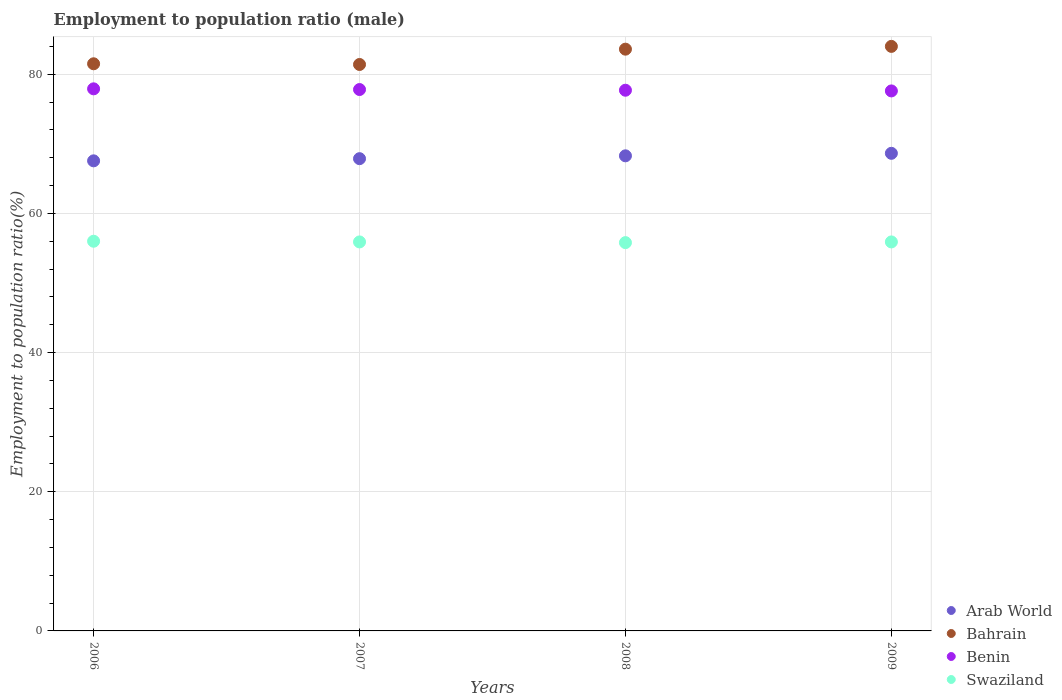How many different coloured dotlines are there?
Ensure brevity in your answer.  4. Across all years, what is the maximum employment to population ratio in Swaziland?
Ensure brevity in your answer.  56. Across all years, what is the minimum employment to population ratio in Swaziland?
Your answer should be very brief. 55.8. In which year was the employment to population ratio in Arab World minimum?
Your answer should be compact. 2006. What is the total employment to population ratio in Benin in the graph?
Keep it short and to the point. 311. What is the difference between the employment to population ratio in Swaziland in 2006 and that in 2009?
Your answer should be very brief. 0.1. What is the average employment to population ratio in Arab World per year?
Offer a terse response. 68.08. In the year 2006, what is the difference between the employment to population ratio in Benin and employment to population ratio in Swaziland?
Provide a succinct answer. 21.9. In how many years, is the employment to population ratio in Swaziland greater than 64 %?
Offer a very short reply. 0. What is the ratio of the employment to population ratio in Bahrain in 2006 to that in 2008?
Your answer should be very brief. 0.97. Is the employment to population ratio in Benin in 2006 less than that in 2007?
Offer a very short reply. No. What is the difference between the highest and the second highest employment to population ratio in Swaziland?
Offer a terse response. 0.1. What is the difference between the highest and the lowest employment to population ratio in Bahrain?
Your answer should be very brief. 2.6. In how many years, is the employment to population ratio in Swaziland greater than the average employment to population ratio in Swaziland taken over all years?
Ensure brevity in your answer.  3. Is the sum of the employment to population ratio in Bahrain in 2006 and 2007 greater than the maximum employment to population ratio in Swaziland across all years?
Your answer should be compact. Yes. Is it the case that in every year, the sum of the employment to population ratio in Swaziland and employment to population ratio in Bahrain  is greater than the sum of employment to population ratio in Arab World and employment to population ratio in Benin?
Keep it short and to the point. Yes. Is it the case that in every year, the sum of the employment to population ratio in Arab World and employment to population ratio in Swaziland  is greater than the employment to population ratio in Bahrain?
Give a very brief answer. Yes. Does the employment to population ratio in Benin monotonically increase over the years?
Ensure brevity in your answer.  No. Is the employment to population ratio in Arab World strictly less than the employment to population ratio in Bahrain over the years?
Your answer should be compact. Yes. How many dotlines are there?
Make the answer very short. 4. How many years are there in the graph?
Provide a short and direct response. 4. Are the values on the major ticks of Y-axis written in scientific E-notation?
Offer a terse response. No. Does the graph contain grids?
Keep it short and to the point. Yes. Where does the legend appear in the graph?
Provide a short and direct response. Bottom right. What is the title of the graph?
Provide a short and direct response. Employment to population ratio (male). What is the label or title of the X-axis?
Your answer should be very brief. Years. What is the label or title of the Y-axis?
Your response must be concise. Employment to population ratio(%). What is the Employment to population ratio(%) of Arab World in 2006?
Provide a short and direct response. 67.55. What is the Employment to population ratio(%) in Bahrain in 2006?
Offer a very short reply. 81.5. What is the Employment to population ratio(%) of Benin in 2006?
Make the answer very short. 77.9. What is the Employment to population ratio(%) in Arab World in 2007?
Give a very brief answer. 67.86. What is the Employment to population ratio(%) in Bahrain in 2007?
Offer a very short reply. 81.4. What is the Employment to population ratio(%) in Benin in 2007?
Provide a short and direct response. 77.8. What is the Employment to population ratio(%) in Swaziland in 2007?
Provide a short and direct response. 55.9. What is the Employment to population ratio(%) in Arab World in 2008?
Ensure brevity in your answer.  68.27. What is the Employment to population ratio(%) in Bahrain in 2008?
Keep it short and to the point. 83.6. What is the Employment to population ratio(%) of Benin in 2008?
Offer a very short reply. 77.7. What is the Employment to population ratio(%) in Swaziland in 2008?
Your answer should be compact. 55.8. What is the Employment to population ratio(%) of Arab World in 2009?
Make the answer very short. 68.63. What is the Employment to population ratio(%) in Benin in 2009?
Provide a short and direct response. 77.6. What is the Employment to population ratio(%) of Swaziland in 2009?
Offer a terse response. 55.9. Across all years, what is the maximum Employment to population ratio(%) of Arab World?
Keep it short and to the point. 68.63. Across all years, what is the maximum Employment to population ratio(%) in Benin?
Ensure brevity in your answer.  77.9. Across all years, what is the maximum Employment to population ratio(%) in Swaziland?
Ensure brevity in your answer.  56. Across all years, what is the minimum Employment to population ratio(%) of Arab World?
Your answer should be compact. 67.55. Across all years, what is the minimum Employment to population ratio(%) in Bahrain?
Keep it short and to the point. 81.4. Across all years, what is the minimum Employment to population ratio(%) of Benin?
Your answer should be very brief. 77.6. Across all years, what is the minimum Employment to population ratio(%) in Swaziland?
Ensure brevity in your answer.  55.8. What is the total Employment to population ratio(%) of Arab World in the graph?
Make the answer very short. 272.32. What is the total Employment to population ratio(%) in Bahrain in the graph?
Provide a short and direct response. 330.5. What is the total Employment to population ratio(%) in Benin in the graph?
Offer a very short reply. 311. What is the total Employment to population ratio(%) in Swaziland in the graph?
Make the answer very short. 223.6. What is the difference between the Employment to population ratio(%) of Arab World in 2006 and that in 2007?
Provide a succinct answer. -0.31. What is the difference between the Employment to population ratio(%) of Swaziland in 2006 and that in 2007?
Ensure brevity in your answer.  0.1. What is the difference between the Employment to population ratio(%) in Arab World in 2006 and that in 2008?
Give a very brief answer. -0.72. What is the difference between the Employment to population ratio(%) of Benin in 2006 and that in 2008?
Provide a short and direct response. 0.2. What is the difference between the Employment to population ratio(%) in Swaziland in 2006 and that in 2008?
Make the answer very short. 0.2. What is the difference between the Employment to population ratio(%) of Arab World in 2006 and that in 2009?
Make the answer very short. -1.08. What is the difference between the Employment to population ratio(%) of Swaziland in 2006 and that in 2009?
Make the answer very short. 0.1. What is the difference between the Employment to population ratio(%) of Arab World in 2007 and that in 2008?
Provide a succinct answer. -0.41. What is the difference between the Employment to population ratio(%) in Bahrain in 2007 and that in 2008?
Give a very brief answer. -2.2. What is the difference between the Employment to population ratio(%) in Benin in 2007 and that in 2008?
Provide a short and direct response. 0.1. What is the difference between the Employment to population ratio(%) of Arab World in 2007 and that in 2009?
Ensure brevity in your answer.  -0.77. What is the difference between the Employment to population ratio(%) in Bahrain in 2007 and that in 2009?
Give a very brief answer. -2.6. What is the difference between the Employment to population ratio(%) of Benin in 2007 and that in 2009?
Your response must be concise. 0.2. What is the difference between the Employment to population ratio(%) of Arab World in 2008 and that in 2009?
Give a very brief answer. -0.36. What is the difference between the Employment to population ratio(%) in Benin in 2008 and that in 2009?
Keep it short and to the point. 0.1. What is the difference between the Employment to population ratio(%) of Swaziland in 2008 and that in 2009?
Your response must be concise. -0.1. What is the difference between the Employment to population ratio(%) in Arab World in 2006 and the Employment to population ratio(%) in Bahrain in 2007?
Provide a short and direct response. -13.85. What is the difference between the Employment to population ratio(%) in Arab World in 2006 and the Employment to population ratio(%) in Benin in 2007?
Offer a terse response. -10.25. What is the difference between the Employment to population ratio(%) of Arab World in 2006 and the Employment to population ratio(%) of Swaziland in 2007?
Keep it short and to the point. 11.65. What is the difference between the Employment to population ratio(%) of Bahrain in 2006 and the Employment to population ratio(%) of Benin in 2007?
Ensure brevity in your answer.  3.7. What is the difference between the Employment to population ratio(%) of Bahrain in 2006 and the Employment to population ratio(%) of Swaziland in 2007?
Your answer should be compact. 25.6. What is the difference between the Employment to population ratio(%) of Benin in 2006 and the Employment to population ratio(%) of Swaziland in 2007?
Offer a very short reply. 22. What is the difference between the Employment to population ratio(%) in Arab World in 2006 and the Employment to population ratio(%) in Bahrain in 2008?
Provide a succinct answer. -16.05. What is the difference between the Employment to population ratio(%) in Arab World in 2006 and the Employment to population ratio(%) in Benin in 2008?
Offer a terse response. -10.15. What is the difference between the Employment to population ratio(%) in Arab World in 2006 and the Employment to population ratio(%) in Swaziland in 2008?
Offer a terse response. 11.75. What is the difference between the Employment to population ratio(%) of Bahrain in 2006 and the Employment to population ratio(%) of Swaziland in 2008?
Give a very brief answer. 25.7. What is the difference between the Employment to population ratio(%) in Benin in 2006 and the Employment to population ratio(%) in Swaziland in 2008?
Keep it short and to the point. 22.1. What is the difference between the Employment to population ratio(%) of Arab World in 2006 and the Employment to population ratio(%) of Bahrain in 2009?
Your answer should be very brief. -16.45. What is the difference between the Employment to population ratio(%) of Arab World in 2006 and the Employment to population ratio(%) of Benin in 2009?
Your response must be concise. -10.05. What is the difference between the Employment to population ratio(%) in Arab World in 2006 and the Employment to population ratio(%) in Swaziland in 2009?
Provide a succinct answer. 11.65. What is the difference between the Employment to population ratio(%) in Bahrain in 2006 and the Employment to population ratio(%) in Benin in 2009?
Provide a short and direct response. 3.9. What is the difference between the Employment to population ratio(%) in Bahrain in 2006 and the Employment to population ratio(%) in Swaziland in 2009?
Provide a succinct answer. 25.6. What is the difference between the Employment to population ratio(%) of Benin in 2006 and the Employment to population ratio(%) of Swaziland in 2009?
Keep it short and to the point. 22. What is the difference between the Employment to population ratio(%) in Arab World in 2007 and the Employment to population ratio(%) in Bahrain in 2008?
Keep it short and to the point. -15.74. What is the difference between the Employment to population ratio(%) of Arab World in 2007 and the Employment to population ratio(%) of Benin in 2008?
Give a very brief answer. -9.84. What is the difference between the Employment to population ratio(%) in Arab World in 2007 and the Employment to population ratio(%) in Swaziland in 2008?
Offer a very short reply. 12.06. What is the difference between the Employment to population ratio(%) in Bahrain in 2007 and the Employment to population ratio(%) in Swaziland in 2008?
Provide a succinct answer. 25.6. What is the difference between the Employment to population ratio(%) in Benin in 2007 and the Employment to population ratio(%) in Swaziland in 2008?
Your answer should be very brief. 22. What is the difference between the Employment to population ratio(%) of Arab World in 2007 and the Employment to population ratio(%) of Bahrain in 2009?
Your answer should be very brief. -16.14. What is the difference between the Employment to population ratio(%) of Arab World in 2007 and the Employment to population ratio(%) of Benin in 2009?
Keep it short and to the point. -9.74. What is the difference between the Employment to population ratio(%) in Arab World in 2007 and the Employment to population ratio(%) in Swaziland in 2009?
Offer a very short reply. 11.96. What is the difference between the Employment to population ratio(%) in Benin in 2007 and the Employment to population ratio(%) in Swaziland in 2009?
Provide a short and direct response. 21.9. What is the difference between the Employment to population ratio(%) in Arab World in 2008 and the Employment to population ratio(%) in Bahrain in 2009?
Offer a terse response. -15.73. What is the difference between the Employment to population ratio(%) in Arab World in 2008 and the Employment to population ratio(%) in Benin in 2009?
Provide a short and direct response. -9.33. What is the difference between the Employment to population ratio(%) in Arab World in 2008 and the Employment to population ratio(%) in Swaziland in 2009?
Ensure brevity in your answer.  12.37. What is the difference between the Employment to population ratio(%) of Bahrain in 2008 and the Employment to population ratio(%) of Benin in 2009?
Your response must be concise. 6. What is the difference between the Employment to population ratio(%) of Bahrain in 2008 and the Employment to population ratio(%) of Swaziland in 2009?
Make the answer very short. 27.7. What is the difference between the Employment to population ratio(%) in Benin in 2008 and the Employment to population ratio(%) in Swaziland in 2009?
Offer a terse response. 21.8. What is the average Employment to population ratio(%) of Arab World per year?
Ensure brevity in your answer.  68.08. What is the average Employment to population ratio(%) of Bahrain per year?
Offer a terse response. 82.62. What is the average Employment to population ratio(%) of Benin per year?
Your response must be concise. 77.75. What is the average Employment to population ratio(%) in Swaziland per year?
Provide a short and direct response. 55.9. In the year 2006, what is the difference between the Employment to population ratio(%) of Arab World and Employment to population ratio(%) of Bahrain?
Provide a short and direct response. -13.95. In the year 2006, what is the difference between the Employment to population ratio(%) in Arab World and Employment to population ratio(%) in Benin?
Make the answer very short. -10.35. In the year 2006, what is the difference between the Employment to population ratio(%) in Arab World and Employment to population ratio(%) in Swaziland?
Offer a terse response. 11.55. In the year 2006, what is the difference between the Employment to population ratio(%) in Bahrain and Employment to population ratio(%) in Benin?
Offer a terse response. 3.6. In the year 2006, what is the difference between the Employment to population ratio(%) of Bahrain and Employment to population ratio(%) of Swaziland?
Give a very brief answer. 25.5. In the year 2006, what is the difference between the Employment to population ratio(%) of Benin and Employment to population ratio(%) of Swaziland?
Provide a succinct answer. 21.9. In the year 2007, what is the difference between the Employment to population ratio(%) in Arab World and Employment to population ratio(%) in Bahrain?
Keep it short and to the point. -13.54. In the year 2007, what is the difference between the Employment to population ratio(%) of Arab World and Employment to population ratio(%) of Benin?
Ensure brevity in your answer.  -9.94. In the year 2007, what is the difference between the Employment to population ratio(%) of Arab World and Employment to population ratio(%) of Swaziland?
Offer a terse response. 11.96. In the year 2007, what is the difference between the Employment to population ratio(%) in Bahrain and Employment to population ratio(%) in Swaziland?
Provide a short and direct response. 25.5. In the year 2007, what is the difference between the Employment to population ratio(%) in Benin and Employment to population ratio(%) in Swaziland?
Offer a terse response. 21.9. In the year 2008, what is the difference between the Employment to population ratio(%) in Arab World and Employment to population ratio(%) in Bahrain?
Your answer should be very brief. -15.33. In the year 2008, what is the difference between the Employment to population ratio(%) of Arab World and Employment to population ratio(%) of Benin?
Keep it short and to the point. -9.43. In the year 2008, what is the difference between the Employment to population ratio(%) of Arab World and Employment to population ratio(%) of Swaziland?
Your answer should be very brief. 12.47. In the year 2008, what is the difference between the Employment to population ratio(%) in Bahrain and Employment to population ratio(%) in Benin?
Your answer should be very brief. 5.9. In the year 2008, what is the difference between the Employment to population ratio(%) of Bahrain and Employment to population ratio(%) of Swaziland?
Keep it short and to the point. 27.8. In the year 2008, what is the difference between the Employment to population ratio(%) of Benin and Employment to population ratio(%) of Swaziland?
Provide a succinct answer. 21.9. In the year 2009, what is the difference between the Employment to population ratio(%) in Arab World and Employment to population ratio(%) in Bahrain?
Offer a very short reply. -15.37. In the year 2009, what is the difference between the Employment to population ratio(%) of Arab World and Employment to population ratio(%) of Benin?
Your response must be concise. -8.97. In the year 2009, what is the difference between the Employment to population ratio(%) in Arab World and Employment to population ratio(%) in Swaziland?
Your answer should be compact. 12.73. In the year 2009, what is the difference between the Employment to population ratio(%) in Bahrain and Employment to population ratio(%) in Swaziland?
Your answer should be compact. 28.1. In the year 2009, what is the difference between the Employment to population ratio(%) of Benin and Employment to population ratio(%) of Swaziland?
Offer a very short reply. 21.7. What is the ratio of the Employment to population ratio(%) of Arab World in 2006 to that in 2007?
Give a very brief answer. 1. What is the ratio of the Employment to population ratio(%) in Swaziland in 2006 to that in 2007?
Provide a succinct answer. 1. What is the ratio of the Employment to population ratio(%) in Bahrain in 2006 to that in 2008?
Offer a very short reply. 0.97. What is the ratio of the Employment to population ratio(%) in Benin in 2006 to that in 2008?
Your response must be concise. 1. What is the ratio of the Employment to population ratio(%) of Swaziland in 2006 to that in 2008?
Provide a succinct answer. 1. What is the ratio of the Employment to population ratio(%) in Arab World in 2006 to that in 2009?
Give a very brief answer. 0.98. What is the ratio of the Employment to population ratio(%) of Bahrain in 2006 to that in 2009?
Your answer should be compact. 0.97. What is the ratio of the Employment to population ratio(%) in Bahrain in 2007 to that in 2008?
Ensure brevity in your answer.  0.97. What is the ratio of the Employment to population ratio(%) in Swaziland in 2007 to that in 2008?
Offer a very short reply. 1. What is the ratio of the Employment to population ratio(%) of Arab World in 2007 to that in 2009?
Your response must be concise. 0.99. What is the ratio of the Employment to population ratio(%) of Benin in 2007 to that in 2009?
Keep it short and to the point. 1. What is the ratio of the Employment to population ratio(%) in Arab World in 2008 to that in 2009?
Offer a terse response. 0.99. What is the ratio of the Employment to population ratio(%) in Bahrain in 2008 to that in 2009?
Keep it short and to the point. 1. What is the ratio of the Employment to population ratio(%) of Benin in 2008 to that in 2009?
Keep it short and to the point. 1. What is the ratio of the Employment to population ratio(%) of Swaziland in 2008 to that in 2009?
Your response must be concise. 1. What is the difference between the highest and the second highest Employment to population ratio(%) of Arab World?
Offer a very short reply. 0.36. What is the difference between the highest and the second highest Employment to population ratio(%) in Bahrain?
Offer a very short reply. 0.4. What is the difference between the highest and the second highest Employment to population ratio(%) of Benin?
Keep it short and to the point. 0.1. What is the difference between the highest and the second highest Employment to population ratio(%) in Swaziland?
Your response must be concise. 0.1. What is the difference between the highest and the lowest Employment to population ratio(%) in Arab World?
Offer a terse response. 1.08. What is the difference between the highest and the lowest Employment to population ratio(%) of Bahrain?
Provide a short and direct response. 2.6. What is the difference between the highest and the lowest Employment to population ratio(%) of Benin?
Provide a succinct answer. 0.3. What is the difference between the highest and the lowest Employment to population ratio(%) in Swaziland?
Provide a succinct answer. 0.2. 